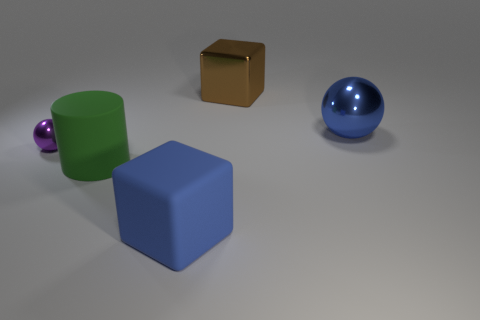Add 2 tiny yellow balls. How many objects exist? 7 Subtract all cylinders. How many objects are left? 4 Subtract all gray shiny spheres. Subtract all big blue metal objects. How many objects are left? 4 Add 1 big cylinders. How many big cylinders are left? 2 Add 5 large rubber cubes. How many large rubber cubes exist? 6 Subtract 0 yellow spheres. How many objects are left? 5 Subtract 2 blocks. How many blocks are left? 0 Subtract all cyan balls. Subtract all blue blocks. How many balls are left? 2 Subtract all green cylinders. How many brown blocks are left? 1 